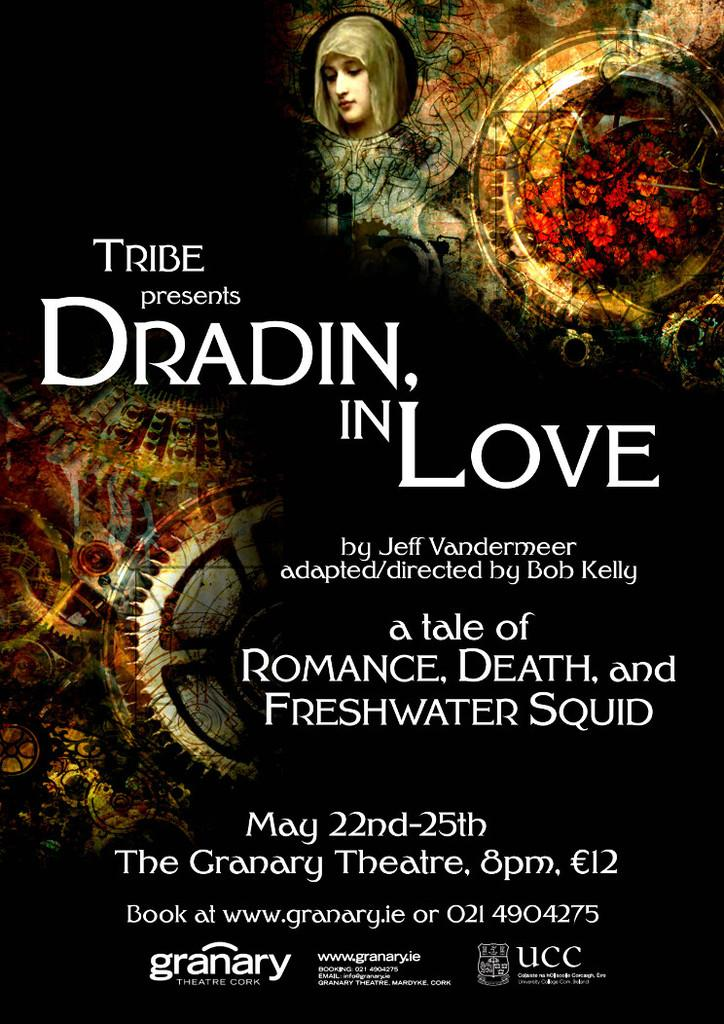Provide a one-sentence caption for the provided image. An advertisement for Dradin in Love which is playing at The Granary Theatre. 